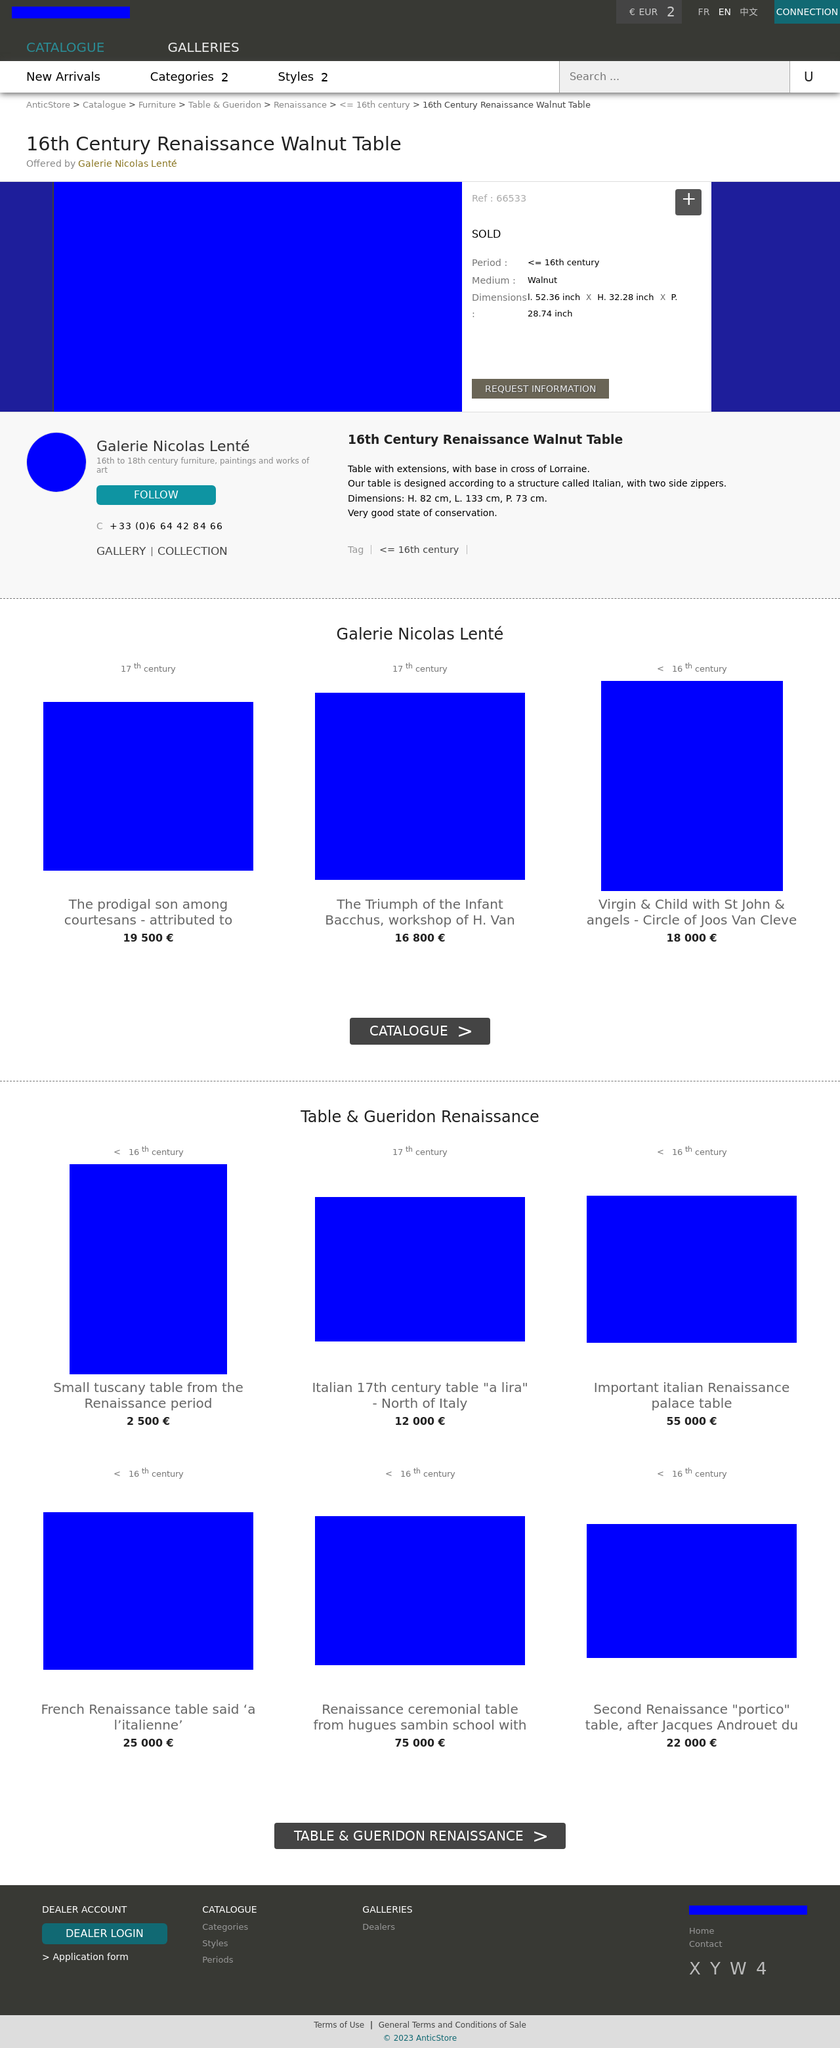What should I look for in authenticity and care if I consider purchasing a piece like the Renaissance table? Authenticity in Renaissance furniture can often be assessed through examining the materials, construction techniques, and aging signs consistent with the period. For a piece like this walnut table, expect to see solid walnut wood, pegged or mortise-and-tenon joints, and perhaps even some tool marks from hand crafting. Caring for such a piece would involve regulating temperature and humidity, using gentle wood cleaning methods, and avoiding harsh chemicals that could damage the old wood and finishes. 